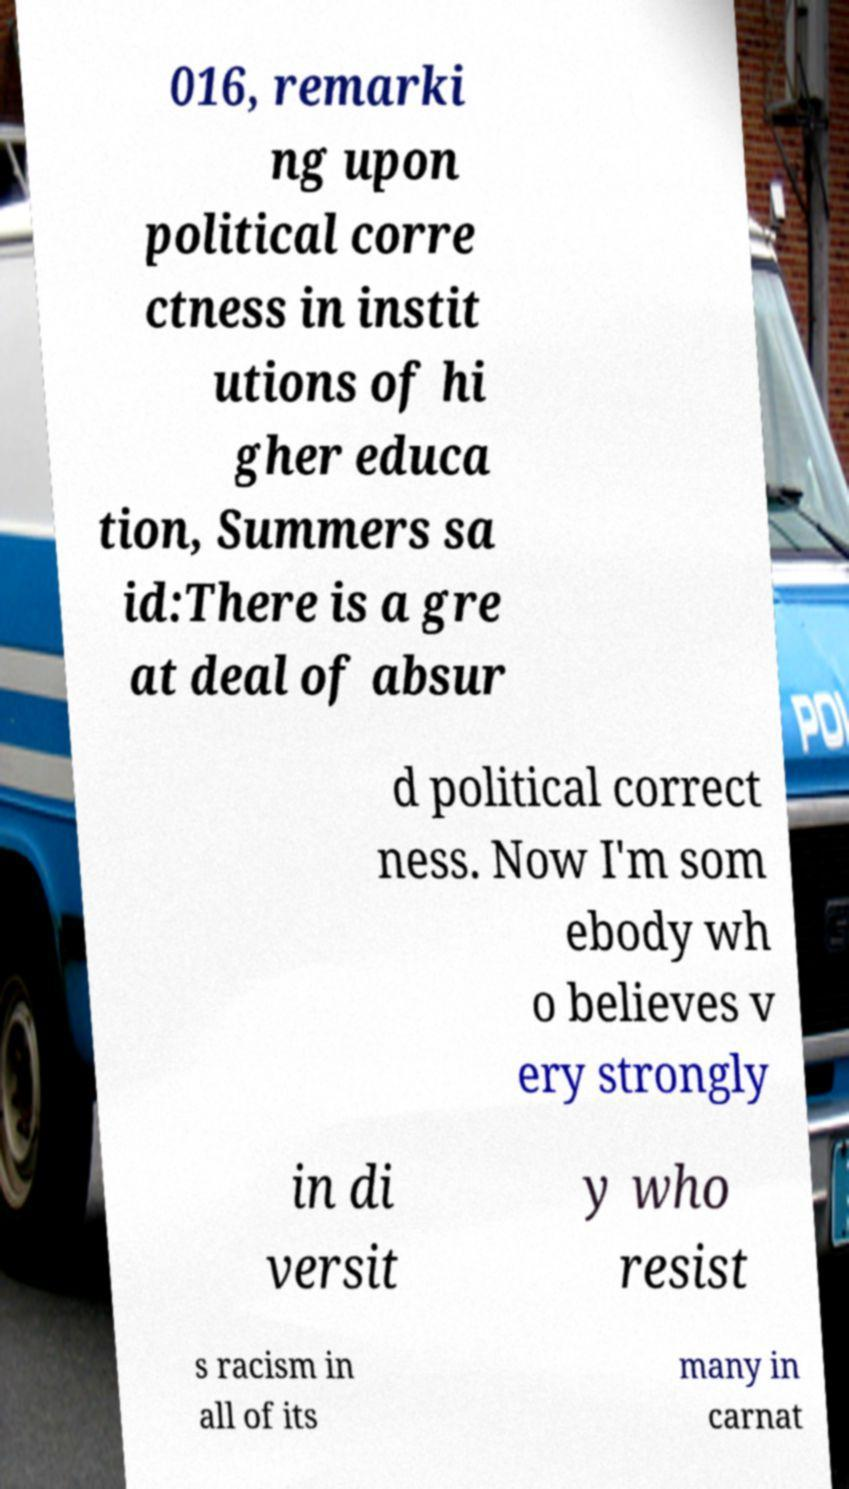Can you accurately transcribe the text from the provided image for me? 016, remarki ng upon political corre ctness in instit utions of hi gher educa tion, Summers sa id:There is a gre at deal of absur d political correct ness. Now I'm som ebody wh o believes v ery strongly in di versit y who resist s racism in all of its many in carnat 